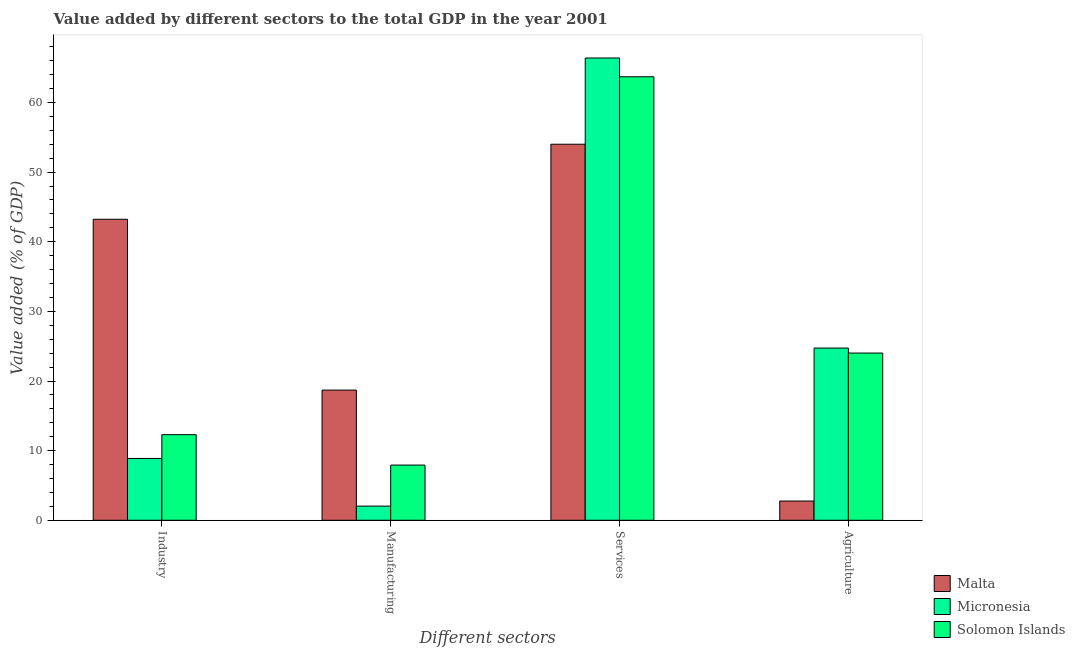How many different coloured bars are there?
Offer a very short reply. 3. How many groups of bars are there?
Offer a terse response. 4. Are the number of bars per tick equal to the number of legend labels?
Your response must be concise. Yes. How many bars are there on the 2nd tick from the left?
Offer a terse response. 3. What is the label of the 2nd group of bars from the left?
Ensure brevity in your answer.  Manufacturing. What is the value added by industrial sector in Solomon Islands?
Your answer should be very brief. 12.29. Across all countries, what is the maximum value added by services sector?
Make the answer very short. 66.39. Across all countries, what is the minimum value added by industrial sector?
Your answer should be compact. 8.88. In which country was the value added by industrial sector maximum?
Provide a short and direct response. Malta. In which country was the value added by manufacturing sector minimum?
Keep it short and to the point. Micronesia. What is the total value added by services sector in the graph?
Your answer should be compact. 184.09. What is the difference between the value added by industrial sector in Malta and that in Solomon Islands?
Keep it short and to the point. 30.94. What is the difference between the value added by industrial sector in Solomon Islands and the value added by manufacturing sector in Micronesia?
Your answer should be compact. 10.26. What is the average value added by industrial sector per country?
Your answer should be very brief. 21.47. What is the difference between the value added by agricultural sector and value added by industrial sector in Solomon Islands?
Ensure brevity in your answer.  11.72. What is the ratio of the value added by manufacturing sector in Solomon Islands to that in Malta?
Your answer should be very brief. 0.42. What is the difference between the highest and the second highest value added by agricultural sector?
Your answer should be very brief. 0.72. What is the difference between the highest and the lowest value added by industrial sector?
Offer a very short reply. 34.35. In how many countries, is the value added by manufacturing sector greater than the average value added by manufacturing sector taken over all countries?
Provide a short and direct response. 1. Is the sum of the value added by manufacturing sector in Solomon Islands and Micronesia greater than the maximum value added by services sector across all countries?
Your answer should be very brief. No. What does the 2nd bar from the left in Manufacturing represents?
Give a very brief answer. Micronesia. What does the 3rd bar from the right in Agriculture represents?
Your answer should be compact. Malta. Is it the case that in every country, the sum of the value added by industrial sector and value added by manufacturing sector is greater than the value added by services sector?
Provide a short and direct response. No. Are the values on the major ticks of Y-axis written in scientific E-notation?
Ensure brevity in your answer.  No. Does the graph contain grids?
Keep it short and to the point. No. Where does the legend appear in the graph?
Offer a very short reply. Bottom right. How many legend labels are there?
Ensure brevity in your answer.  3. How are the legend labels stacked?
Your answer should be compact. Vertical. What is the title of the graph?
Ensure brevity in your answer.  Value added by different sectors to the total GDP in the year 2001. What is the label or title of the X-axis?
Offer a terse response. Different sectors. What is the label or title of the Y-axis?
Provide a short and direct response. Value added (% of GDP). What is the Value added (% of GDP) of Malta in Industry?
Make the answer very short. 43.23. What is the Value added (% of GDP) of Micronesia in Industry?
Your answer should be very brief. 8.88. What is the Value added (% of GDP) of Solomon Islands in Industry?
Give a very brief answer. 12.29. What is the Value added (% of GDP) in Malta in Manufacturing?
Make the answer very short. 18.69. What is the Value added (% of GDP) in Micronesia in Manufacturing?
Your response must be concise. 2.04. What is the Value added (% of GDP) of Solomon Islands in Manufacturing?
Make the answer very short. 7.93. What is the Value added (% of GDP) of Malta in Services?
Keep it short and to the point. 54.01. What is the Value added (% of GDP) of Micronesia in Services?
Give a very brief answer. 66.39. What is the Value added (% of GDP) in Solomon Islands in Services?
Make the answer very short. 63.69. What is the Value added (% of GDP) of Malta in Agriculture?
Give a very brief answer. 2.76. What is the Value added (% of GDP) in Micronesia in Agriculture?
Ensure brevity in your answer.  24.73. What is the Value added (% of GDP) of Solomon Islands in Agriculture?
Provide a short and direct response. 24.01. Across all Different sectors, what is the maximum Value added (% of GDP) of Malta?
Give a very brief answer. 54.01. Across all Different sectors, what is the maximum Value added (% of GDP) of Micronesia?
Your response must be concise. 66.39. Across all Different sectors, what is the maximum Value added (% of GDP) in Solomon Islands?
Give a very brief answer. 63.69. Across all Different sectors, what is the minimum Value added (% of GDP) of Malta?
Your answer should be very brief. 2.76. Across all Different sectors, what is the minimum Value added (% of GDP) of Micronesia?
Your answer should be compact. 2.04. Across all Different sectors, what is the minimum Value added (% of GDP) in Solomon Islands?
Ensure brevity in your answer.  7.93. What is the total Value added (% of GDP) of Malta in the graph?
Provide a short and direct response. 118.69. What is the total Value added (% of GDP) in Micronesia in the graph?
Ensure brevity in your answer.  102.03. What is the total Value added (% of GDP) in Solomon Islands in the graph?
Offer a very short reply. 107.93. What is the difference between the Value added (% of GDP) of Malta in Industry and that in Manufacturing?
Your answer should be compact. 24.54. What is the difference between the Value added (% of GDP) in Micronesia in Industry and that in Manufacturing?
Offer a terse response. 6.84. What is the difference between the Value added (% of GDP) of Solomon Islands in Industry and that in Manufacturing?
Provide a succinct answer. 4.37. What is the difference between the Value added (% of GDP) of Malta in Industry and that in Services?
Keep it short and to the point. -10.77. What is the difference between the Value added (% of GDP) in Micronesia in Industry and that in Services?
Ensure brevity in your answer.  -57.51. What is the difference between the Value added (% of GDP) of Solomon Islands in Industry and that in Services?
Make the answer very short. -51.4. What is the difference between the Value added (% of GDP) of Malta in Industry and that in Agriculture?
Offer a terse response. 40.47. What is the difference between the Value added (% of GDP) of Micronesia in Industry and that in Agriculture?
Your response must be concise. -15.86. What is the difference between the Value added (% of GDP) of Solomon Islands in Industry and that in Agriculture?
Provide a short and direct response. -11.72. What is the difference between the Value added (% of GDP) in Malta in Manufacturing and that in Services?
Offer a very short reply. -35.31. What is the difference between the Value added (% of GDP) of Micronesia in Manufacturing and that in Services?
Your answer should be compact. -64.36. What is the difference between the Value added (% of GDP) of Solomon Islands in Manufacturing and that in Services?
Your answer should be compact. -55.76. What is the difference between the Value added (% of GDP) in Malta in Manufacturing and that in Agriculture?
Your answer should be very brief. 15.93. What is the difference between the Value added (% of GDP) of Micronesia in Manufacturing and that in Agriculture?
Make the answer very short. -22.7. What is the difference between the Value added (% of GDP) of Solomon Islands in Manufacturing and that in Agriculture?
Your response must be concise. -16.09. What is the difference between the Value added (% of GDP) of Malta in Services and that in Agriculture?
Ensure brevity in your answer.  51.24. What is the difference between the Value added (% of GDP) of Micronesia in Services and that in Agriculture?
Provide a succinct answer. 41.66. What is the difference between the Value added (% of GDP) in Solomon Islands in Services and that in Agriculture?
Your response must be concise. 39.68. What is the difference between the Value added (% of GDP) in Malta in Industry and the Value added (% of GDP) in Micronesia in Manufacturing?
Offer a very short reply. 41.2. What is the difference between the Value added (% of GDP) in Malta in Industry and the Value added (% of GDP) in Solomon Islands in Manufacturing?
Your answer should be compact. 35.3. What is the difference between the Value added (% of GDP) of Micronesia in Industry and the Value added (% of GDP) of Solomon Islands in Manufacturing?
Offer a terse response. 0.95. What is the difference between the Value added (% of GDP) of Malta in Industry and the Value added (% of GDP) of Micronesia in Services?
Keep it short and to the point. -23.16. What is the difference between the Value added (% of GDP) in Malta in Industry and the Value added (% of GDP) in Solomon Islands in Services?
Make the answer very short. -20.46. What is the difference between the Value added (% of GDP) in Micronesia in Industry and the Value added (% of GDP) in Solomon Islands in Services?
Give a very brief answer. -54.82. What is the difference between the Value added (% of GDP) in Malta in Industry and the Value added (% of GDP) in Micronesia in Agriculture?
Ensure brevity in your answer.  18.5. What is the difference between the Value added (% of GDP) of Malta in Industry and the Value added (% of GDP) of Solomon Islands in Agriculture?
Offer a terse response. 19.22. What is the difference between the Value added (% of GDP) in Micronesia in Industry and the Value added (% of GDP) in Solomon Islands in Agriculture?
Your answer should be compact. -15.14. What is the difference between the Value added (% of GDP) of Malta in Manufacturing and the Value added (% of GDP) of Micronesia in Services?
Provide a succinct answer. -47.7. What is the difference between the Value added (% of GDP) in Malta in Manufacturing and the Value added (% of GDP) in Solomon Islands in Services?
Provide a short and direct response. -45. What is the difference between the Value added (% of GDP) of Micronesia in Manufacturing and the Value added (% of GDP) of Solomon Islands in Services?
Provide a succinct answer. -61.66. What is the difference between the Value added (% of GDP) of Malta in Manufacturing and the Value added (% of GDP) of Micronesia in Agriculture?
Give a very brief answer. -6.04. What is the difference between the Value added (% of GDP) in Malta in Manufacturing and the Value added (% of GDP) in Solomon Islands in Agriculture?
Offer a terse response. -5.32. What is the difference between the Value added (% of GDP) in Micronesia in Manufacturing and the Value added (% of GDP) in Solomon Islands in Agriculture?
Provide a succinct answer. -21.98. What is the difference between the Value added (% of GDP) in Malta in Services and the Value added (% of GDP) in Micronesia in Agriculture?
Offer a terse response. 29.27. What is the difference between the Value added (% of GDP) of Malta in Services and the Value added (% of GDP) of Solomon Islands in Agriculture?
Your answer should be compact. 29.99. What is the difference between the Value added (% of GDP) in Micronesia in Services and the Value added (% of GDP) in Solomon Islands in Agriculture?
Make the answer very short. 42.38. What is the average Value added (% of GDP) in Malta per Different sectors?
Give a very brief answer. 29.67. What is the average Value added (% of GDP) in Micronesia per Different sectors?
Make the answer very short. 25.51. What is the average Value added (% of GDP) of Solomon Islands per Different sectors?
Ensure brevity in your answer.  26.98. What is the difference between the Value added (% of GDP) of Malta and Value added (% of GDP) of Micronesia in Industry?
Ensure brevity in your answer.  34.35. What is the difference between the Value added (% of GDP) of Malta and Value added (% of GDP) of Solomon Islands in Industry?
Your answer should be very brief. 30.94. What is the difference between the Value added (% of GDP) of Micronesia and Value added (% of GDP) of Solomon Islands in Industry?
Ensure brevity in your answer.  -3.42. What is the difference between the Value added (% of GDP) of Malta and Value added (% of GDP) of Micronesia in Manufacturing?
Make the answer very short. 16.66. What is the difference between the Value added (% of GDP) in Malta and Value added (% of GDP) in Solomon Islands in Manufacturing?
Provide a short and direct response. 10.77. What is the difference between the Value added (% of GDP) of Micronesia and Value added (% of GDP) of Solomon Islands in Manufacturing?
Provide a succinct answer. -5.89. What is the difference between the Value added (% of GDP) of Malta and Value added (% of GDP) of Micronesia in Services?
Your answer should be very brief. -12.39. What is the difference between the Value added (% of GDP) of Malta and Value added (% of GDP) of Solomon Islands in Services?
Your response must be concise. -9.69. What is the difference between the Value added (% of GDP) of Micronesia and Value added (% of GDP) of Solomon Islands in Services?
Give a very brief answer. 2.7. What is the difference between the Value added (% of GDP) in Malta and Value added (% of GDP) in Micronesia in Agriculture?
Keep it short and to the point. -21.97. What is the difference between the Value added (% of GDP) of Malta and Value added (% of GDP) of Solomon Islands in Agriculture?
Keep it short and to the point. -21.25. What is the difference between the Value added (% of GDP) in Micronesia and Value added (% of GDP) in Solomon Islands in Agriculture?
Offer a very short reply. 0.72. What is the ratio of the Value added (% of GDP) in Malta in Industry to that in Manufacturing?
Provide a short and direct response. 2.31. What is the ratio of the Value added (% of GDP) in Micronesia in Industry to that in Manufacturing?
Your response must be concise. 4.36. What is the ratio of the Value added (% of GDP) of Solomon Islands in Industry to that in Manufacturing?
Your answer should be very brief. 1.55. What is the ratio of the Value added (% of GDP) in Malta in Industry to that in Services?
Ensure brevity in your answer.  0.8. What is the ratio of the Value added (% of GDP) in Micronesia in Industry to that in Services?
Give a very brief answer. 0.13. What is the ratio of the Value added (% of GDP) in Solomon Islands in Industry to that in Services?
Provide a succinct answer. 0.19. What is the ratio of the Value added (% of GDP) in Malta in Industry to that in Agriculture?
Give a very brief answer. 15.64. What is the ratio of the Value added (% of GDP) of Micronesia in Industry to that in Agriculture?
Give a very brief answer. 0.36. What is the ratio of the Value added (% of GDP) in Solomon Islands in Industry to that in Agriculture?
Provide a succinct answer. 0.51. What is the ratio of the Value added (% of GDP) in Malta in Manufacturing to that in Services?
Offer a terse response. 0.35. What is the ratio of the Value added (% of GDP) of Micronesia in Manufacturing to that in Services?
Make the answer very short. 0.03. What is the ratio of the Value added (% of GDP) in Solomon Islands in Manufacturing to that in Services?
Offer a terse response. 0.12. What is the ratio of the Value added (% of GDP) of Malta in Manufacturing to that in Agriculture?
Your answer should be very brief. 6.76. What is the ratio of the Value added (% of GDP) in Micronesia in Manufacturing to that in Agriculture?
Your answer should be compact. 0.08. What is the ratio of the Value added (% of GDP) in Solomon Islands in Manufacturing to that in Agriculture?
Your answer should be very brief. 0.33. What is the ratio of the Value added (% of GDP) in Malta in Services to that in Agriculture?
Give a very brief answer. 19.53. What is the ratio of the Value added (% of GDP) of Micronesia in Services to that in Agriculture?
Provide a short and direct response. 2.68. What is the ratio of the Value added (% of GDP) in Solomon Islands in Services to that in Agriculture?
Provide a succinct answer. 2.65. What is the difference between the highest and the second highest Value added (% of GDP) of Malta?
Provide a short and direct response. 10.77. What is the difference between the highest and the second highest Value added (% of GDP) of Micronesia?
Ensure brevity in your answer.  41.66. What is the difference between the highest and the second highest Value added (% of GDP) in Solomon Islands?
Offer a terse response. 39.68. What is the difference between the highest and the lowest Value added (% of GDP) in Malta?
Your response must be concise. 51.24. What is the difference between the highest and the lowest Value added (% of GDP) in Micronesia?
Provide a short and direct response. 64.36. What is the difference between the highest and the lowest Value added (% of GDP) in Solomon Islands?
Your response must be concise. 55.76. 